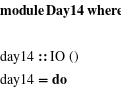Convert code to text. <code><loc_0><loc_0><loc_500><loc_500><_Haskell_>module Day14 where

day14 :: IO ()
day14 = do</code> 